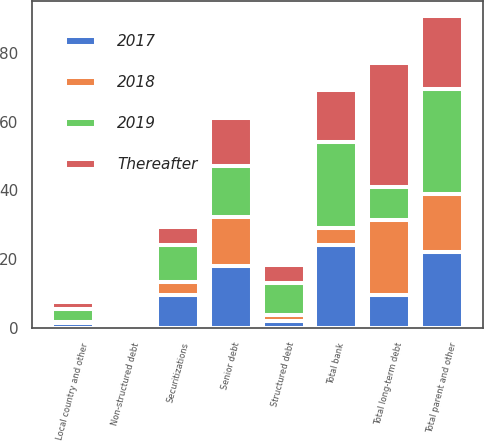Convert chart to OTSL. <chart><loc_0><loc_0><loc_500><loc_500><stacked_bar_chart><ecel><fcel>Senior debt<fcel>Structured debt<fcel>Non-structured debt<fcel>Total parent and other<fcel>Securitizations<fcel>Local country and other<fcel>Total bank<fcel>Total long-term debt<nl><fcel>2019<fcel>14.9<fcel>9.5<fcel>0.7<fcel>30.4<fcel>10.7<fcel>3.9<fcel>25.1<fcel>9.5<nl><fcel>Thereafter<fcel>14<fcel>5.1<fcel>0.5<fcel>21.1<fcel>5.3<fcel>1.9<fcel>15<fcel>36.1<nl><fcel>2017<fcel>18.2<fcel>2.1<fcel>0.6<fcel>22<fcel>9.5<fcel>1.4<fcel>24.1<fcel>9.5<nl><fcel>2018<fcel>14<fcel>1.6<fcel>0.2<fcel>17.1<fcel>3.9<fcel>0.4<fcel>4.9<fcel>22<nl></chart> 